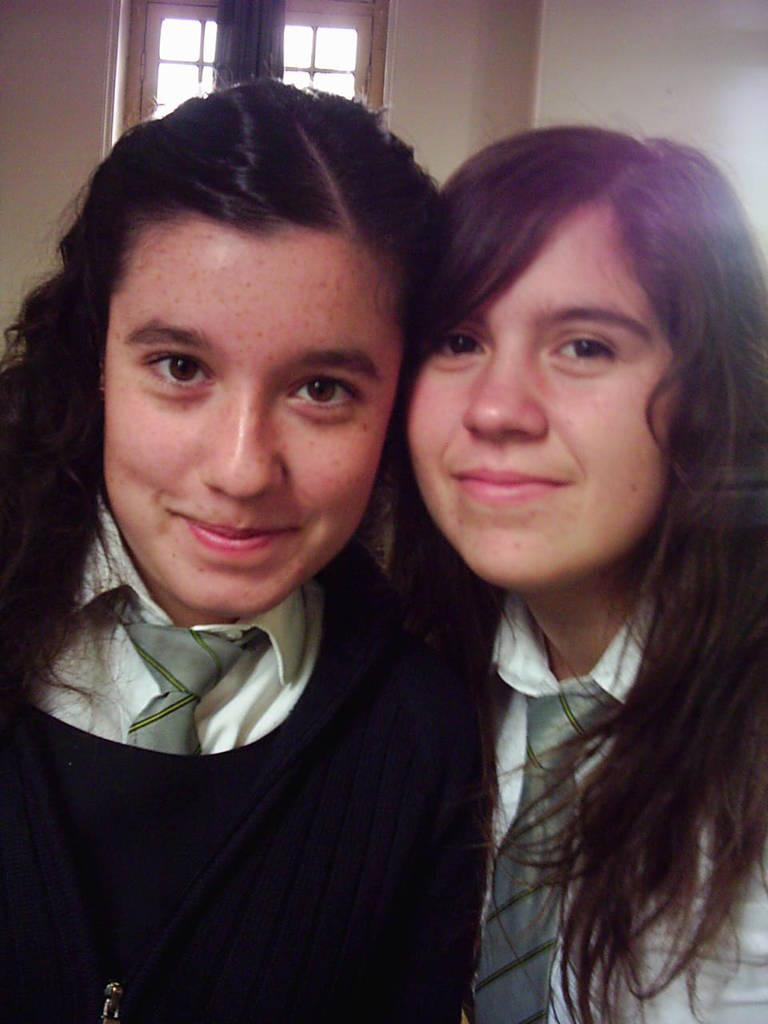How many girls are in the image? There are two girls in the image. What are the girls wearing? One girl is wearing a black jacket, and the other girl is wearing a white T-shirt. What expressions do the girls have? Both girls are smiling in the image. Where is the girl in the black jacket located in the image? The girl in the black jacket is on the left side of the image. Where is the girl in the white T-shirt located in the image? The girl in the white T-shirt is on the right side of the image. What type of knife is the girl in the white T-shirt holding in the image? There is no knife present in the image; both girls are smiling and not holding any objects. 